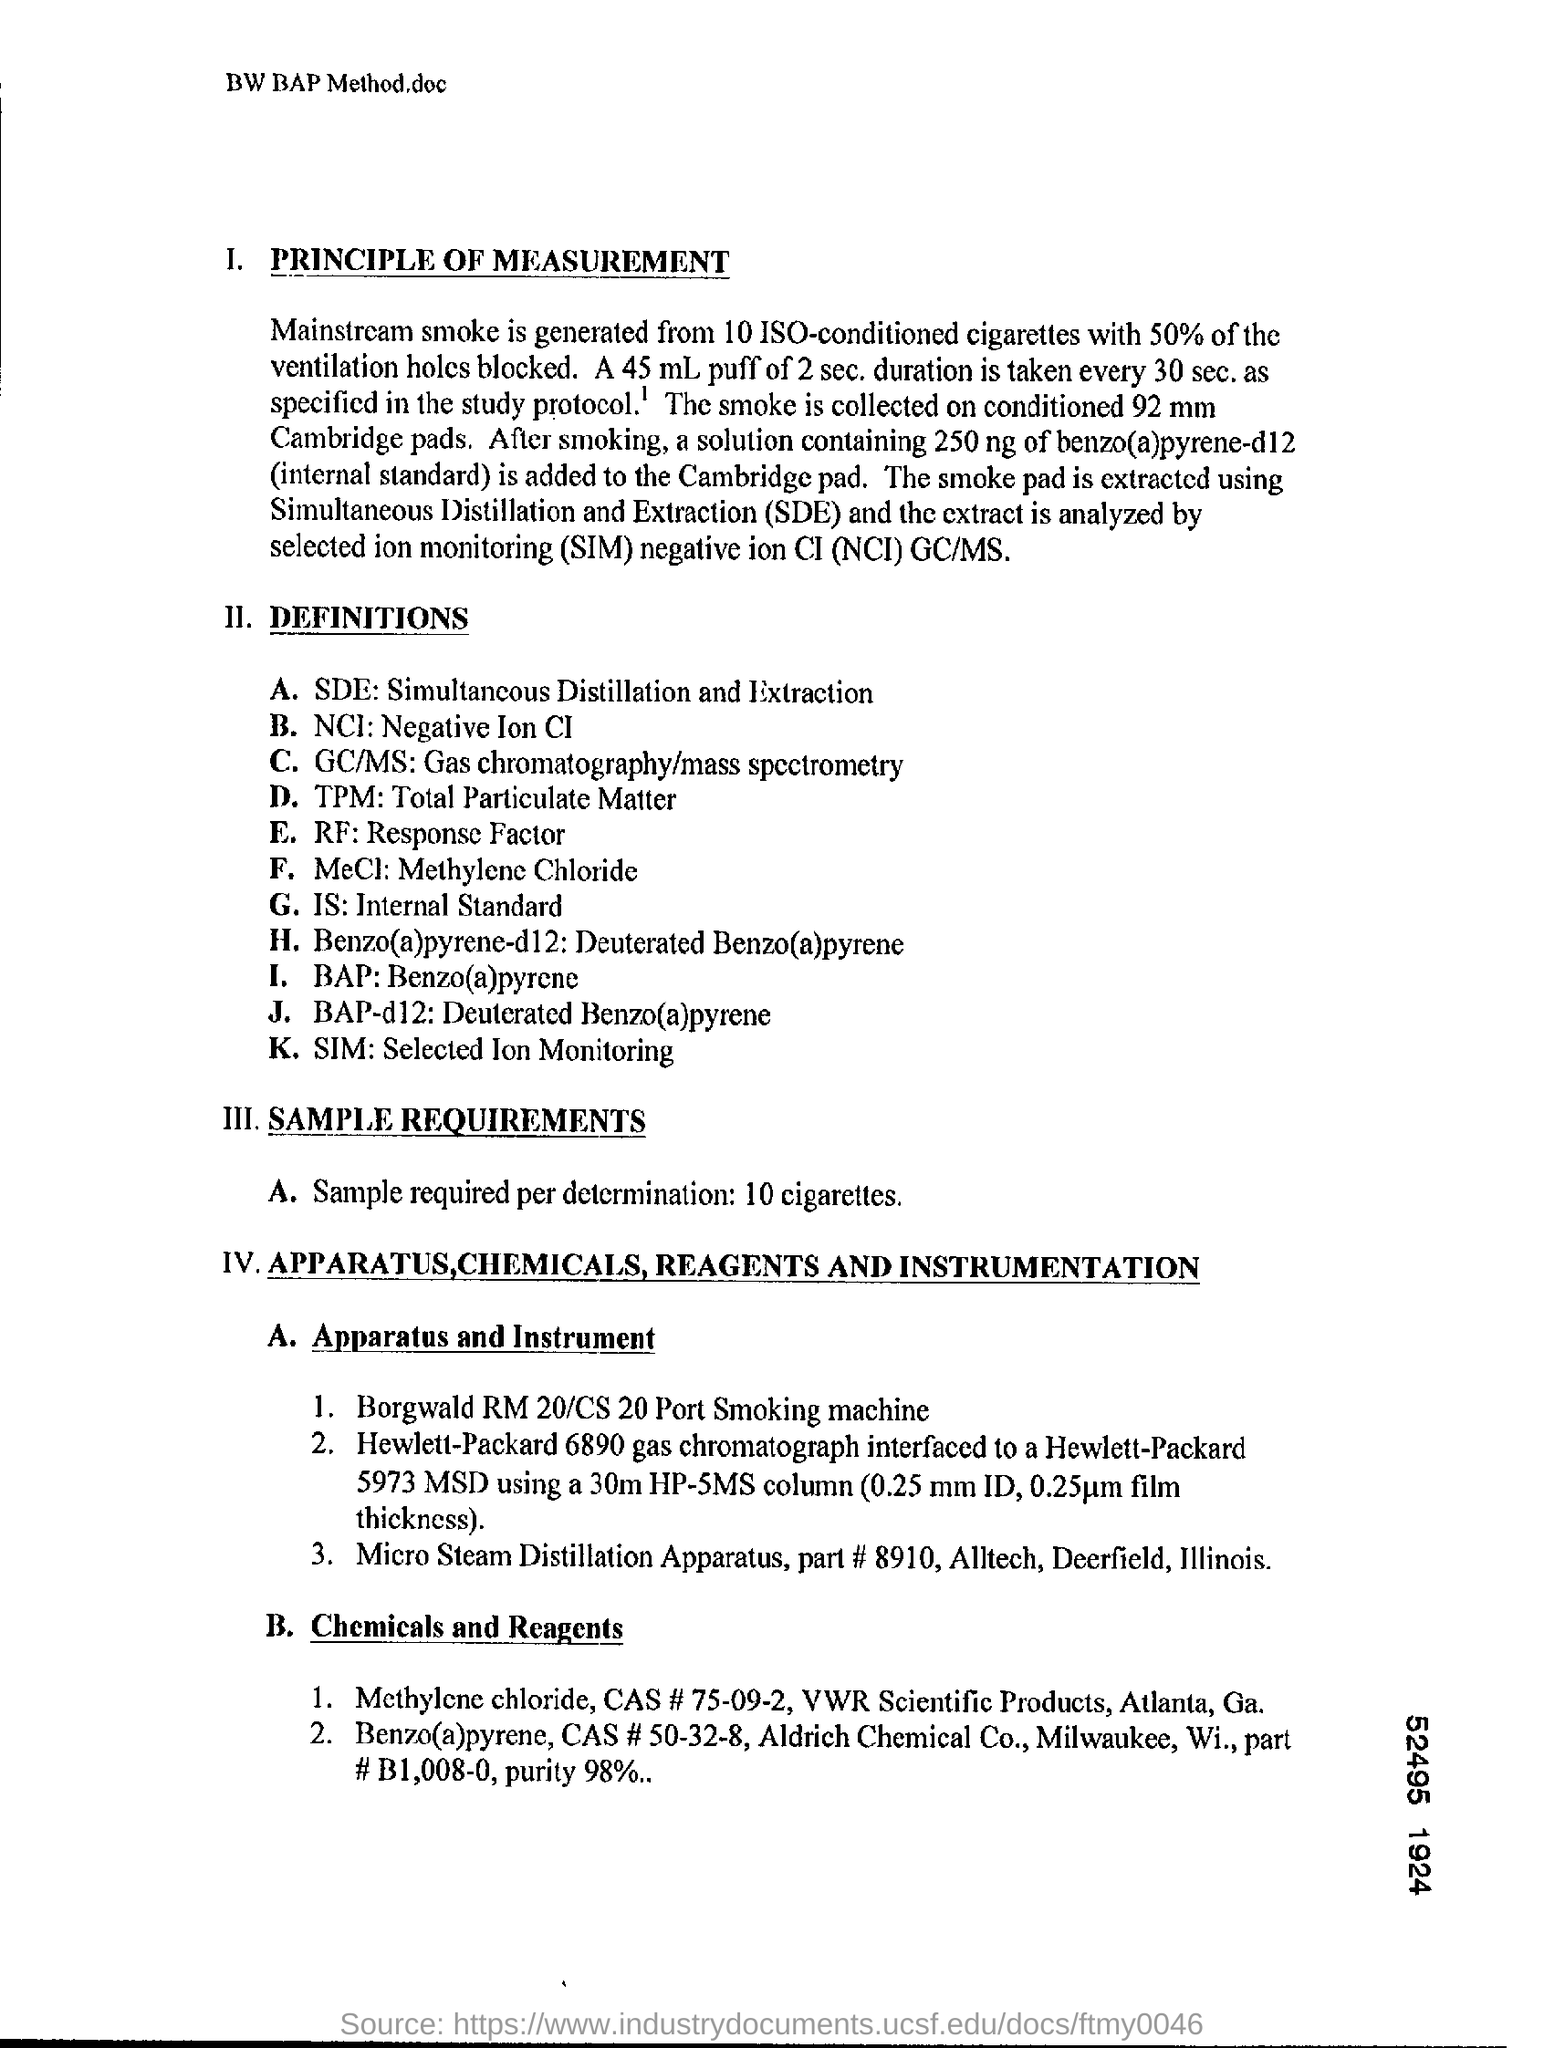What is the fullform of SDE?
Give a very brief answer. Simultaneous Distillation and Extraction. What is the definition of TPM ?
Your response must be concise. Total Particulate Matter. What is the definition of SDE ?
Offer a terse response. Simultaneous Distillation and Extraction. What is the fullform of SIM?
Make the answer very short. Selected ion monitoring. 